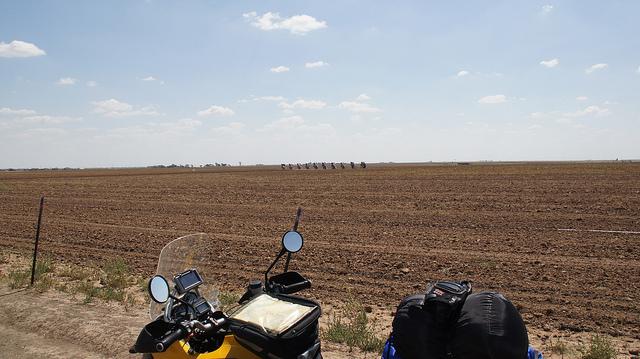Is there any plant life in this picture?
Give a very brief answer. Yes. Is this a field?
Quick response, please. Yes. How many mirrors are there?
Quick response, please. 2. 